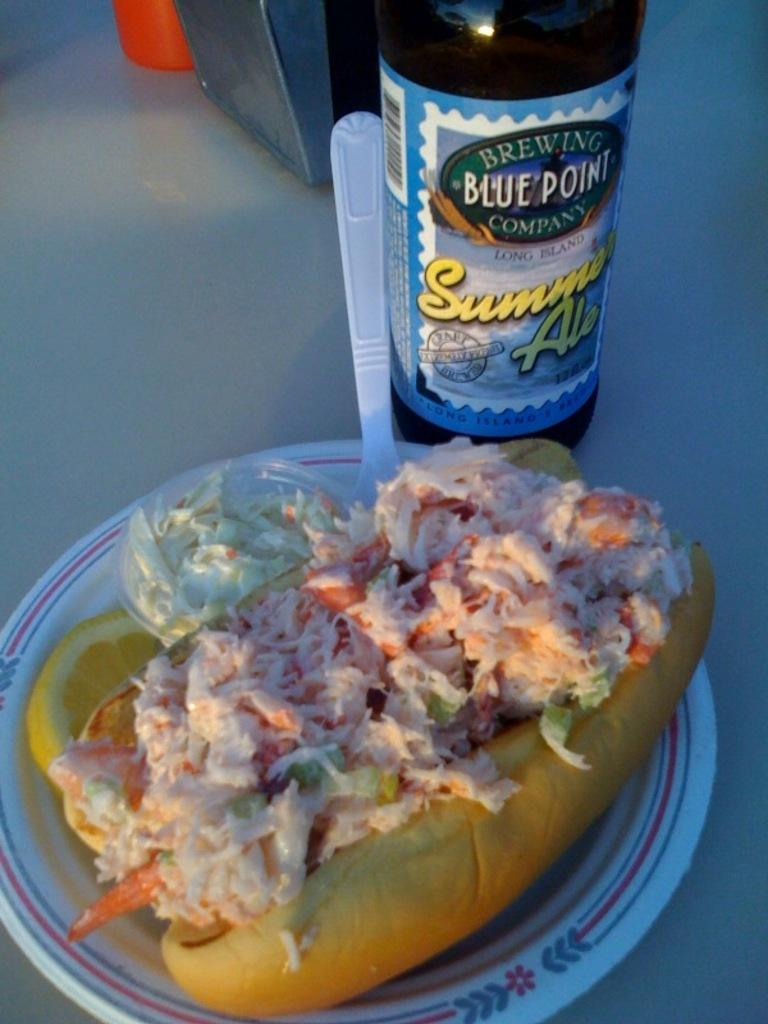<image>
Describe the image concisely. A bottle of Summer Ale from Blue Point Brewing Company is on a table next to a plate of food. 